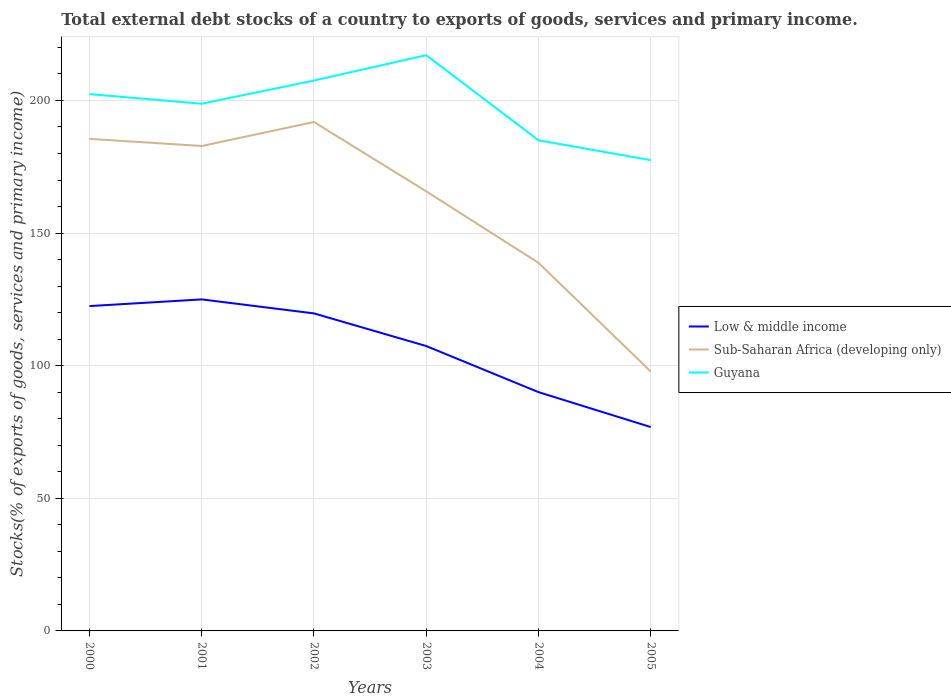Across all years, what is the maximum total debt stocks in Guyana?
Ensure brevity in your answer.  177.49. In which year was the total debt stocks in Guyana maximum?
Your answer should be very brief. 2005. What is the total total debt stocks in Low & middle income in the graph?
Offer a very short reply. 17.38. What is the difference between the highest and the second highest total debt stocks in Guyana?
Your answer should be compact. 39.57. What is the difference between the highest and the lowest total debt stocks in Sub-Saharan Africa (developing only)?
Provide a succinct answer. 4. Is the total debt stocks in Low & middle income strictly greater than the total debt stocks in Sub-Saharan Africa (developing only) over the years?
Keep it short and to the point. Yes. What is the difference between two consecutive major ticks on the Y-axis?
Give a very brief answer. 50. Are the values on the major ticks of Y-axis written in scientific E-notation?
Offer a terse response. No. Does the graph contain grids?
Offer a terse response. Yes. How many legend labels are there?
Your response must be concise. 3. How are the legend labels stacked?
Offer a very short reply. Vertical. What is the title of the graph?
Give a very brief answer. Total external debt stocks of a country to exports of goods, services and primary income. What is the label or title of the X-axis?
Offer a very short reply. Years. What is the label or title of the Y-axis?
Provide a succinct answer. Stocks(% of exports of goods, services and primary income). What is the Stocks(% of exports of goods, services and primary income) in Low & middle income in 2000?
Ensure brevity in your answer.  122.47. What is the Stocks(% of exports of goods, services and primary income) in Sub-Saharan Africa (developing only) in 2000?
Ensure brevity in your answer.  185.52. What is the Stocks(% of exports of goods, services and primary income) of Guyana in 2000?
Provide a short and direct response. 202.39. What is the Stocks(% of exports of goods, services and primary income) of Low & middle income in 2001?
Give a very brief answer. 124.99. What is the Stocks(% of exports of goods, services and primary income) in Sub-Saharan Africa (developing only) in 2001?
Provide a succinct answer. 182.83. What is the Stocks(% of exports of goods, services and primary income) of Guyana in 2001?
Your response must be concise. 198.77. What is the Stocks(% of exports of goods, services and primary income) of Low & middle income in 2002?
Provide a succinct answer. 119.71. What is the Stocks(% of exports of goods, services and primary income) of Sub-Saharan Africa (developing only) in 2002?
Provide a short and direct response. 191.87. What is the Stocks(% of exports of goods, services and primary income) in Guyana in 2002?
Provide a short and direct response. 207.5. What is the Stocks(% of exports of goods, services and primary income) in Low & middle income in 2003?
Keep it short and to the point. 107.4. What is the Stocks(% of exports of goods, services and primary income) in Sub-Saharan Africa (developing only) in 2003?
Give a very brief answer. 165.72. What is the Stocks(% of exports of goods, services and primary income) in Guyana in 2003?
Your answer should be very brief. 217.07. What is the Stocks(% of exports of goods, services and primary income) of Low & middle income in 2004?
Keep it short and to the point. 90.02. What is the Stocks(% of exports of goods, services and primary income) in Sub-Saharan Africa (developing only) in 2004?
Ensure brevity in your answer.  138.77. What is the Stocks(% of exports of goods, services and primary income) in Guyana in 2004?
Provide a short and direct response. 184.98. What is the Stocks(% of exports of goods, services and primary income) in Low & middle income in 2005?
Your answer should be compact. 76.86. What is the Stocks(% of exports of goods, services and primary income) in Sub-Saharan Africa (developing only) in 2005?
Ensure brevity in your answer.  97.79. What is the Stocks(% of exports of goods, services and primary income) in Guyana in 2005?
Give a very brief answer. 177.49. Across all years, what is the maximum Stocks(% of exports of goods, services and primary income) of Low & middle income?
Provide a succinct answer. 124.99. Across all years, what is the maximum Stocks(% of exports of goods, services and primary income) in Sub-Saharan Africa (developing only)?
Provide a short and direct response. 191.87. Across all years, what is the maximum Stocks(% of exports of goods, services and primary income) in Guyana?
Your response must be concise. 217.07. Across all years, what is the minimum Stocks(% of exports of goods, services and primary income) in Low & middle income?
Your response must be concise. 76.86. Across all years, what is the minimum Stocks(% of exports of goods, services and primary income) of Sub-Saharan Africa (developing only)?
Give a very brief answer. 97.79. Across all years, what is the minimum Stocks(% of exports of goods, services and primary income) in Guyana?
Offer a very short reply. 177.49. What is the total Stocks(% of exports of goods, services and primary income) in Low & middle income in the graph?
Provide a succinct answer. 641.46. What is the total Stocks(% of exports of goods, services and primary income) in Sub-Saharan Africa (developing only) in the graph?
Provide a succinct answer. 962.5. What is the total Stocks(% of exports of goods, services and primary income) in Guyana in the graph?
Provide a succinct answer. 1188.2. What is the difference between the Stocks(% of exports of goods, services and primary income) of Low & middle income in 2000 and that in 2001?
Your answer should be compact. -2.51. What is the difference between the Stocks(% of exports of goods, services and primary income) in Sub-Saharan Africa (developing only) in 2000 and that in 2001?
Give a very brief answer. 2.69. What is the difference between the Stocks(% of exports of goods, services and primary income) of Guyana in 2000 and that in 2001?
Give a very brief answer. 3.62. What is the difference between the Stocks(% of exports of goods, services and primary income) in Low & middle income in 2000 and that in 2002?
Offer a very short reply. 2.76. What is the difference between the Stocks(% of exports of goods, services and primary income) of Sub-Saharan Africa (developing only) in 2000 and that in 2002?
Give a very brief answer. -6.35. What is the difference between the Stocks(% of exports of goods, services and primary income) in Guyana in 2000 and that in 2002?
Your answer should be compact. -5.11. What is the difference between the Stocks(% of exports of goods, services and primary income) of Low & middle income in 2000 and that in 2003?
Offer a very short reply. 15.07. What is the difference between the Stocks(% of exports of goods, services and primary income) in Sub-Saharan Africa (developing only) in 2000 and that in 2003?
Your answer should be compact. 19.79. What is the difference between the Stocks(% of exports of goods, services and primary income) of Guyana in 2000 and that in 2003?
Provide a short and direct response. -14.68. What is the difference between the Stocks(% of exports of goods, services and primary income) of Low & middle income in 2000 and that in 2004?
Your answer should be compact. 32.45. What is the difference between the Stocks(% of exports of goods, services and primary income) of Sub-Saharan Africa (developing only) in 2000 and that in 2004?
Provide a succinct answer. 46.75. What is the difference between the Stocks(% of exports of goods, services and primary income) of Guyana in 2000 and that in 2004?
Offer a very short reply. 17.41. What is the difference between the Stocks(% of exports of goods, services and primary income) in Low & middle income in 2000 and that in 2005?
Make the answer very short. 45.61. What is the difference between the Stocks(% of exports of goods, services and primary income) in Sub-Saharan Africa (developing only) in 2000 and that in 2005?
Provide a succinct answer. 87.73. What is the difference between the Stocks(% of exports of goods, services and primary income) of Guyana in 2000 and that in 2005?
Your answer should be compact. 24.9. What is the difference between the Stocks(% of exports of goods, services and primary income) in Low & middle income in 2001 and that in 2002?
Provide a short and direct response. 5.27. What is the difference between the Stocks(% of exports of goods, services and primary income) of Sub-Saharan Africa (developing only) in 2001 and that in 2002?
Keep it short and to the point. -9.04. What is the difference between the Stocks(% of exports of goods, services and primary income) of Guyana in 2001 and that in 2002?
Your answer should be compact. -8.73. What is the difference between the Stocks(% of exports of goods, services and primary income) in Low & middle income in 2001 and that in 2003?
Provide a short and direct response. 17.58. What is the difference between the Stocks(% of exports of goods, services and primary income) of Sub-Saharan Africa (developing only) in 2001 and that in 2003?
Your response must be concise. 17.11. What is the difference between the Stocks(% of exports of goods, services and primary income) of Guyana in 2001 and that in 2003?
Offer a very short reply. -18.3. What is the difference between the Stocks(% of exports of goods, services and primary income) in Low & middle income in 2001 and that in 2004?
Make the answer very short. 34.96. What is the difference between the Stocks(% of exports of goods, services and primary income) in Sub-Saharan Africa (developing only) in 2001 and that in 2004?
Your answer should be compact. 44.06. What is the difference between the Stocks(% of exports of goods, services and primary income) of Guyana in 2001 and that in 2004?
Provide a succinct answer. 13.79. What is the difference between the Stocks(% of exports of goods, services and primary income) in Low & middle income in 2001 and that in 2005?
Offer a terse response. 48.13. What is the difference between the Stocks(% of exports of goods, services and primary income) of Sub-Saharan Africa (developing only) in 2001 and that in 2005?
Keep it short and to the point. 85.04. What is the difference between the Stocks(% of exports of goods, services and primary income) in Guyana in 2001 and that in 2005?
Offer a very short reply. 21.28. What is the difference between the Stocks(% of exports of goods, services and primary income) of Low & middle income in 2002 and that in 2003?
Your answer should be very brief. 12.31. What is the difference between the Stocks(% of exports of goods, services and primary income) in Sub-Saharan Africa (developing only) in 2002 and that in 2003?
Keep it short and to the point. 26.14. What is the difference between the Stocks(% of exports of goods, services and primary income) in Guyana in 2002 and that in 2003?
Ensure brevity in your answer.  -9.57. What is the difference between the Stocks(% of exports of goods, services and primary income) of Low & middle income in 2002 and that in 2004?
Provide a succinct answer. 29.69. What is the difference between the Stocks(% of exports of goods, services and primary income) in Sub-Saharan Africa (developing only) in 2002 and that in 2004?
Make the answer very short. 53.1. What is the difference between the Stocks(% of exports of goods, services and primary income) of Guyana in 2002 and that in 2004?
Your answer should be compact. 22.52. What is the difference between the Stocks(% of exports of goods, services and primary income) of Low & middle income in 2002 and that in 2005?
Provide a short and direct response. 42.86. What is the difference between the Stocks(% of exports of goods, services and primary income) of Sub-Saharan Africa (developing only) in 2002 and that in 2005?
Provide a short and direct response. 94.08. What is the difference between the Stocks(% of exports of goods, services and primary income) in Guyana in 2002 and that in 2005?
Give a very brief answer. 30. What is the difference between the Stocks(% of exports of goods, services and primary income) in Low & middle income in 2003 and that in 2004?
Ensure brevity in your answer.  17.38. What is the difference between the Stocks(% of exports of goods, services and primary income) of Sub-Saharan Africa (developing only) in 2003 and that in 2004?
Ensure brevity in your answer.  26.95. What is the difference between the Stocks(% of exports of goods, services and primary income) of Guyana in 2003 and that in 2004?
Your response must be concise. 32.09. What is the difference between the Stocks(% of exports of goods, services and primary income) of Low & middle income in 2003 and that in 2005?
Make the answer very short. 30.54. What is the difference between the Stocks(% of exports of goods, services and primary income) of Sub-Saharan Africa (developing only) in 2003 and that in 2005?
Your response must be concise. 67.94. What is the difference between the Stocks(% of exports of goods, services and primary income) of Guyana in 2003 and that in 2005?
Offer a very short reply. 39.57. What is the difference between the Stocks(% of exports of goods, services and primary income) in Low & middle income in 2004 and that in 2005?
Keep it short and to the point. 13.16. What is the difference between the Stocks(% of exports of goods, services and primary income) in Sub-Saharan Africa (developing only) in 2004 and that in 2005?
Your answer should be compact. 40.98. What is the difference between the Stocks(% of exports of goods, services and primary income) of Guyana in 2004 and that in 2005?
Make the answer very short. 7.48. What is the difference between the Stocks(% of exports of goods, services and primary income) in Low & middle income in 2000 and the Stocks(% of exports of goods, services and primary income) in Sub-Saharan Africa (developing only) in 2001?
Offer a very short reply. -60.36. What is the difference between the Stocks(% of exports of goods, services and primary income) of Low & middle income in 2000 and the Stocks(% of exports of goods, services and primary income) of Guyana in 2001?
Give a very brief answer. -76.3. What is the difference between the Stocks(% of exports of goods, services and primary income) in Sub-Saharan Africa (developing only) in 2000 and the Stocks(% of exports of goods, services and primary income) in Guyana in 2001?
Your response must be concise. -13.25. What is the difference between the Stocks(% of exports of goods, services and primary income) in Low & middle income in 2000 and the Stocks(% of exports of goods, services and primary income) in Sub-Saharan Africa (developing only) in 2002?
Make the answer very short. -69.39. What is the difference between the Stocks(% of exports of goods, services and primary income) in Low & middle income in 2000 and the Stocks(% of exports of goods, services and primary income) in Guyana in 2002?
Give a very brief answer. -85.03. What is the difference between the Stocks(% of exports of goods, services and primary income) of Sub-Saharan Africa (developing only) in 2000 and the Stocks(% of exports of goods, services and primary income) of Guyana in 2002?
Make the answer very short. -21.98. What is the difference between the Stocks(% of exports of goods, services and primary income) of Low & middle income in 2000 and the Stocks(% of exports of goods, services and primary income) of Sub-Saharan Africa (developing only) in 2003?
Your answer should be compact. -43.25. What is the difference between the Stocks(% of exports of goods, services and primary income) of Low & middle income in 2000 and the Stocks(% of exports of goods, services and primary income) of Guyana in 2003?
Offer a terse response. -94.6. What is the difference between the Stocks(% of exports of goods, services and primary income) of Sub-Saharan Africa (developing only) in 2000 and the Stocks(% of exports of goods, services and primary income) of Guyana in 2003?
Ensure brevity in your answer.  -31.55. What is the difference between the Stocks(% of exports of goods, services and primary income) of Low & middle income in 2000 and the Stocks(% of exports of goods, services and primary income) of Sub-Saharan Africa (developing only) in 2004?
Offer a terse response. -16.3. What is the difference between the Stocks(% of exports of goods, services and primary income) of Low & middle income in 2000 and the Stocks(% of exports of goods, services and primary income) of Guyana in 2004?
Your response must be concise. -62.51. What is the difference between the Stocks(% of exports of goods, services and primary income) in Sub-Saharan Africa (developing only) in 2000 and the Stocks(% of exports of goods, services and primary income) in Guyana in 2004?
Give a very brief answer. 0.54. What is the difference between the Stocks(% of exports of goods, services and primary income) in Low & middle income in 2000 and the Stocks(% of exports of goods, services and primary income) in Sub-Saharan Africa (developing only) in 2005?
Provide a short and direct response. 24.69. What is the difference between the Stocks(% of exports of goods, services and primary income) of Low & middle income in 2000 and the Stocks(% of exports of goods, services and primary income) of Guyana in 2005?
Offer a terse response. -55.02. What is the difference between the Stocks(% of exports of goods, services and primary income) of Sub-Saharan Africa (developing only) in 2000 and the Stocks(% of exports of goods, services and primary income) of Guyana in 2005?
Give a very brief answer. 8.02. What is the difference between the Stocks(% of exports of goods, services and primary income) in Low & middle income in 2001 and the Stocks(% of exports of goods, services and primary income) in Sub-Saharan Africa (developing only) in 2002?
Give a very brief answer. -66.88. What is the difference between the Stocks(% of exports of goods, services and primary income) in Low & middle income in 2001 and the Stocks(% of exports of goods, services and primary income) in Guyana in 2002?
Give a very brief answer. -82.51. What is the difference between the Stocks(% of exports of goods, services and primary income) of Sub-Saharan Africa (developing only) in 2001 and the Stocks(% of exports of goods, services and primary income) of Guyana in 2002?
Provide a succinct answer. -24.67. What is the difference between the Stocks(% of exports of goods, services and primary income) of Low & middle income in 2001 and the Stocks(% of exports of goods, services and primary income) of Sub-Saharan Africa (developing only) in 2003?
Provide a short and direct response. -40.74. What is the difference between the Stocks(% of exports of goods, services and primary income) of Low & middle income in 2001 and the Stocks(% of exports of goods, services and primary income) of Guyana in 2003?
Give a very brief answer. -92.08. What is the difference between the Stocks(% of exports of goods, services and primary income) of Sub-Saharan Africa (developing only) in 2001 and the Stocks(% of exports of goods, services and primary income) of Guyana in 2003?
Provide a succinct answer. -34.24. What is the difference between the Stocks(% of exports of goods, services and primary income) in Low & middle income in 2001 and the Stocks(% of exports of goods, services and primary income) in Sub-Saharan Africa (developing only) in 2004?
Provide a succinct answer. -13.78. What is the difference between the Stocks(% of exports of goods, services and primary income) of Low & middle income in 2001 and the Stocks(% of exports of goods, services and primary income) of Guyana in 2004?
Your response must be concise. -59.99. What is the difference between the Stocks(% of exports of goods, services and primary income) of Sub-Saharan Africa (developing only) in 2001 and the Stocks(% of exports of goods, services and primary income) of Guyana in 2004?
Offer a very short reply. -2.15. What is the difference between the Stocks(% of exports of goods, services and primary income) in Low & middle income in 2001 and the Stocks(% of exports of goods, services and primary income) in Sub-Saharan Africa (developing only) in 2005?
Offer a very short reply. 27.2. What is the difference between the Stocks(% of exports of goods, services and primary income) in Low & middle income in 2001 and the Stocks(% of exports of goods, services and primary income) in Guyana in 2005?
Offer a very short reply. -52.51. What is the difference between the Stocks(% of exports of goods, services and primary income) in Sub-Saharan Africa (developing only) in 2001 and the Stocks(% of exports of goods, services and primary income) in Guyana in 2005?
Your response must be concise. 5.33. What is the difference between the Stocks(% of exports of goods, services and primary income) of Low & middle income in 2002 and the Stocks(% of exports of goods, services and primary income) of Sub-Saharan Africa (developing only) in 2003?
Keep it short and to the point. -46.01. What is the difference between the Stocks(% of exports of goods, services and primary income) of Low & middle income in 2002 and the Stocks(% of exports of goods, services and primary income) of Guyana in 2003?
Ensure brevity in your answer.  -97.35. What is the difference between the Stocks(% of exports of goods, services and primary income) in Sub-Saharan Africa (developing only) in 2002 and the Stocks(% of exports of goods, services and primary income) in Guyana in 2003?
Offer a terse response. -25.2. What is the difference between the Stocks(% of exports of goods, services and primary income) in Low & middle income in 2002 and the Stocks(% of exports of goods, services and primary income) in Sub-Saharan Africa (developing only) in 2004?
Give a very brief answer. -19.06. What is the difference between the Stocks(% of exports of goods, services and primary income) in Low & middle income in 2002 and the Stocks(% of exports of goods, services and primary income) in Guyana in 2004?
Keep it short and to the point. -65.26. What is the difference between the Stocks(% of exports of goods, services and primary income) in Sub-Saharan Africa (developing only) in 2002 and the Stocks(% of exports of goods, services and primary income) in Guyana in 2004?
Offer a terse response. 6.89. What is the difference between the Stocks(% of exports of goods, services and primary income) in Low & middle income in 2002 and the Stocks(% of exports of goods, services and primary income) in Sub-Saharan Africa (developing only) in 2005?
Offer a very short reply. 21.93. What is the difference between the Stocks(% of exports of goods, services and primary income) of Low & middle income in 2002 and the Stocks(% of exports of goods, services and primary income) of Guyana in 2005?
Offer a terse response. -57.78. What is the difference between the Stocks(% of exports of goods, services and primary income) in Sub-Saharan Africa (developing only) in 2002 and the Stocks(% of exports of goods, services and primary income) in Guyana in 2005?
Keep it short and to the point. 14.37. What is the difference between the Stocks(% of exports of goods, services and primary income) of Low & middle income in 2003 and the Stocks(% of exports of goods, services and primary income) of Sub-Saharan Africa (developing only) in 2004?
Your response must be concise. -31.37. What is the difference between the Stocks(% of exports of goods, services and primary income) in Low & middle income in 2003 and the Stocks(% of exports of goods, services and primary income) in Guyana in 2004?
Offer a very short reply. -77.58. What is the difference between the Stocks(% of exports of goods, services and primary income) of Sub-Saharan Africa (developing only) in 2003 and the Stocks(% of exports of goods, services and primary income) of Guyana in 2004?
Offer a terse response. -19.25. What is the difference between the Stocks(% of exports of goods, services and primary income) of Low & middle income in 2003 and the Stocks(% of exports of goods, services and primary income) of Sub-Saharan Africa (developing only) in 2005?
Provide a succinct answer. 9.62. What is the difference between the Stocks(% of exports of goods, services and primary income) in Low & middle income in 2003 and the Stocks(% of exports of goods, services and primary income) in Guyana in 2005?
Make the answer very short. -70.09. What is the difference between the Stocks(% of exports of goods, services and primary income) of Sub-Saharan Africa (developing only) in 2003 and the Stocks(% of exports of goods, services and primary income) of Guyana in 2005?
Your response must be concise. -11.77. What is the difference between the Stocks(% of exports of goods, services and primary income) of Low & middle income in 2004 and the Stocks(% of exports of goods, services and primary income) of Sub-Saharan Africa (developing only) in 2005?
Ensure brevity in your answer.  -7.76. What is the difference between the Stocks(% of exports of goods, services and primary income) in Low & middle income in 2004 and the Stocks(% of exports of goods, services and primary income) in Guyana in 2005?
Your response must be concise. -87.47. What is the difference between the Stocks(% of exports of goods, services and primary income) in Sub-Saharan Africa (developing only) in 2004 and the Stocks(% of exports of goods, services and primary income) in Guyana in 2005?
Provide a succinct answer. -38.72. What is the average Stocks(% of exports of goods, services and primary income) in Low & middle income per year?
Provide a succinct answer. 106.91. What is the average Stocks(% of exports of goods, services and primary income) in Sub-Saharan Africa (developing only) per year?
Give a very brief answer. 160.42. What is the average Stocks(% of exports of goods, services and primary income) of Guyana per year?
Offer a terse response. 198.03. In the year 2000, what is the difference between the Stocks(% of exports of goods, services and primary income) of Low & middle income and Stocks(% of exports of goods, services and primary income) of Sub-Saharan Africa (developing only)?
Provide a short and direct response. -63.05. In the year 2000, what is the difference between the Stocks(% of exports of goods, services and primary income) in Low & middle income and Stocks(% of exports of goods, services and primary income) in Guyana?
Your answer should be compact. -79.92. In the year 2000, what is the difference between the Stocks(% of exports of goods, services and primary income) of Sub-Saharan Africa (developing only) and Stocks(% of exports of goods, services and primary income) of Guyana?
Offer a terse response. -16.87. In the year 2001, what is the difference between the Stocks(% of exports of goods, services and primary income) of Low & middle income and Stocks(% of exports of goods, services and primary income) of Sub-Saharan Africa (developing only)?
Your answer should be very brief. -57.84. In the year 2001, what is the difference between the Stocks(% of exports of goods, services and primary income) in Low & middle income and Stocks(% of exports of goods, services and primary income) in Guyana?
Provide a succinct answer. -73.78. In the year 2001, what is the difference between the Stocks(% of exports of goods, services and primary income) in Sub-Saharan Africa (developing only) and Stocks(% of exports of goods, services and primary income) in Guyana?
Your answer should be very brief. -15.94. In the year 2002, what is the difference between the Stocks(% of exports of goods, services and primary income) in Low & middle income and Stocks(% of exports of goods, services and primary income) in Sub-Saharan Africa (developing only)?
Offer a terse response. -72.15. In the year 2002, what is the difference between the Stocks(% of exports of goods, services and primary income) of Low & middle income and Stocks(% of exports of goods, services and primary income) of Guyana?
Offer a very short reply. -87.79. In the year 2002, what is the difference between the Stocks(% of exports of goods, services and primary income) in Sub-Saharan Africa (developing only) and Stocks(% of exports of goods, services and primary income) in Guyana?
Ensure brevity in your answer.  -15.63. In the year 2003, what is the difference between the Stocks(% of exports of goods, services and primary income) of Low & middle income and Stocks(% of exports of goods, services and primary income) of Sub-Saharan Africa (developing only)?
Give a very brief answer. -58.32. In the year 2003, what is the difference between the Stocks(% of exports of goods, services and primary income) of Low & middle income and Stocks(% of exports of goods, services and primary income) of Guyana?
Provide a short and direct response. -109.67. In the year 2003, what is the difference between the Stocks(% of exports of goods, services and primary income) in Sub-Saharan Africa (developing only) and Stocks(% of exports of goods, services and primary income) in Guyana?
Offer a very short reply. -51.34. In the year 2004, what is the difference between the Stocks(% of exports of goods, services and primary income) in Low & middle income and Stocks(% of exports of goods, services and primary income) in Sub-Saharan Africa (developing only)?
Ensure brevity in your answer.  -48.75. In the year 2004, what is the difference between the Stocks(% of exports of goods, services and primary income) in Low & middle income and Stocks(% of exports of goods, services and primary income) in Guyana?
Provide a succinct answer. -94.95. In the year 2004, what is the difference between the Stocks(% of exports of goods, services and primary income) in Sub-Saharan Africa (developing only) and Stocks(% of exports of goods, services and primary income) in Guyana?
Ensure brevity in your answer.  -46.21. In the year 2005, what is the difference between the Stocks(% of exports of goods, services and primary income) of Low & middle income and Stocks(% of exports of goods, services and primary income) of Sub-Saharan Africa (developing only)?
Offer a very short reply. -20.93. In the year 2005, what is the difference between the Stocks(% of exports of goods, services and primary income) in Low & middle income and Stocks(% of exports of goods, services and primary income) in Guyana?
Make the answer very short. -100.64. In the year 2005, what is the difference between the Stocks(% of exports of goods, services and primary income) of Sub-Saharan Africa (developing only) and Stocks(% of exports of goods, services and primary income) of Guyana?
Provide a succinct answer. -79.71. What is the ratio of the Stocks(% of exports of goods, services and primary income) in Low & middle income in 2000 to that in 2001?
Provide a succinct answer. 0.98. What is the ratio of the Stocks(% of exports of goods, services and primary income) of Sub-Saharan Africa (developing only) in 2000 to that in 2001?
Provide a short and direct response. 1.01. What is the ratio of the Stocks(% of exports of goods, services and primary income) in Guyana in 2000 to that in 2001?
Your answer should be very brief. 1.02. What is the ratio of the Stocks(% of exports of goods, services and primary income) of Sub-Saharan Africa (developing only) in 2000 to that in 2002?
Keep it short and to the point. 0.97. What is the ratio of the Stocks(% of exports of goods, services and primary income) in Guyana in 2000 to that in 2002?
Ensure brevity in your answer.  0.98. What is the ratio of the Stocks(% of exports of goods, services and primary income) in Low & middle income in 2000 to that in 2003?
Keep it short and to the point. 1.14. What is the ratio of the Stocks(% of exports of goods, services and primary income) in Sub-Saharan Africa (developing only) in 2000 to that in 2003?
Your response must be concise. 1.12. What is the ratio of the Stocks(% of exports of goods, services and primary income) in Guyana in 2000 to that in 2003?
Make the answer very short. 0.93. What is the ratio of the Stocks(% of exports of goods, services and primary income) in Low & middle income in 2000 to that in 2004?
Provide a short and direct response. 1.36. What is the ratio of the Stocks(% of exports of goods, services and primary income) in Sub-Saharan Africa (developing only) in 2000 to that in 2004?
Offer a terse response. 1.34. What is the ratio of the Stocks(% of exports of goods, services and primary income) in Guyana in 2000 to that in 2004?
Ensure brevity in your answer.  1.09. What is the ratio of the Stocks(% of exports of goods, services and primary income) in Low & middle income in 2000 to that in 2005?
Provide a short and direct response. 1.59. What is the ratio of the Stocks(% of exports of goods, services and primary income) in Sub-Saharan Africa (developing only) in 2000 to that in 2005?
Make the answer very short. 1.9. What is the ratio of the Stocks(% of exports of goods, services and primary income) in Guyana in 2000 to that in 2005?
Offer a terse response. 1.14. What is the ratio of the Stocks(% of exports of goods, services and primary income) in Low & middle income in 2001 to that in 2002?
Give a very brief answer. 1.04. What is the ratio of the Stocks(% of exports of goods, services and primary income) of Sub-Saharan Africa (developing only) in 2001 to that in 2002?
Ensure brevity in your answer.  0.95. What is the ratio of the Stocks(% of exports of goods, services and primary income) in Guyana in 2001 to that in 2002?
Your answer should be very brief. 0.96. What is the ratio of the Stocks(% of exports of goods, services and primary income) in Low & middle income in 2001 to that in 2003?
Your answer should be very brief. 1.16. What is the ratio of the Stocks(% of exports of goods, services and primary income) of Sub-Saharan Africa (developing only) in 2001 to that in 2003?
Make the answer very short. 1.1. What is the ratio of the Stocks(% of exports of goods, services and primary income) in Guyana in 2001 to that in 2003?
Your response must be concise. 0.92. What is the ratio of the Stocks(% of exports of goods, services and primary income) in Low & middle income in 2001 to that in 2004?
Make the answer very short. 1.39. What is the ratio of the Stocks(% of exports of goods, services and primary income) in Sub-Saharan Africa (developing only) in 2001 to that in 2004?
Provide a succinct answer. 1.32. What is the ratio of the Stocks(% of exports of goods, services and primary income) in Guyana in 2001 to that in 2004?
Make the answer very short. 1.07. What is the ratio of the Stocks(% of exports of goods, services and primary income) in Low & middle income in 2001 to that in 2005?
Your answer should be very brief. 1.63. What is the ratio of the Stocks(% of exports of goods, services and primary income) in Sub-Saharan Africa (developing only) in 2001 to that in 2005?
Offer a very short reply. 1.87. What is the ratio of the Stocks(% of exports of goods, services and primary income) of Guyana in 2001 to that in 2005?
Your answer should be compact. 1.12. What is the ratio of the Stocks(% of exports of goods, services and primary income) in Low & middle income in 2002 to that in 2003?
Offer a very short reply. 1.11. What is the ratio of the Stocks(% of exports of goods, services and primary income) in Sub-Saharan Africa (developing only) in 2002 to that in 2003?
Offer a very short reply. 1.16. What is the ratio of the Stocks(% of exports of goods, services and primary income) in Guyana in 2002 to that in 2003?
Offer a terse response. 0.96. What is the ratio of the Stocks(% of exports of goods, services and primary income) in Low & middle income in 2002 to that in 2004?
Your answer should be compact. 1.33. What is the ratio of the Stocks(% of exports of goods, services and primary income) of Sub-Saharan Africa (developing only) in 2002 to that in 2004?
Your answer should be very brief. 1.38. What is the ratio of the Stocks(% of exports of goods, services and primary income) in Guyana in 2002 to that in 2004?
Your response must be concise. 1.12. What is the ratio of the Stocks(% of exports of goods, services and primary income) in Low & middle income in 2002 to that in 2005?
Keep it short and to the point. 1.56. What is the ratio of the Stocks(% of exports of goods, services and primary income) in Sub-Saharan Africa (developing only) in 2002 to that in 2005?
Provide a short and direct response. 1.96. What is the ratio of the Stocks(% of exports of goods, services and primary income) in Guyana in 2002 to that in 2005?
Your answer should be compact. 1.17. What is the ratio of the Stocks(% of exports of goods, services and primary income) in Low & middle income in 2003 to that in 2004?
Your answer should be compact. 1.19. What is the ratio of the Stocks(% of exports of goods, services and primary income) of Sub-Saharan Africa (developing only) in 2003 to that in 2004?
Provide a short and direct response. 1.19. What is the ratio of the Stocks(% of exports of goods, services and primary income) in Guyana in 2003 to that in 2004?
Give a very brief answer. 1.17. What is the ratio of the Stocks(% of exports of goods, services and primary income) in Low & middle income in 2003 to that in 2005?
Make the answer very short. 1.4. What is the ratio of the Stocks(% of exports of goods, services and primary income) of Sub-Saharan Africa (developing only) in 2003 to that in 2005?
Give a very brief answer. 1.69. What is the ratio of the Stocks(% of exports of goods, services and primary income) in Guyana in 2003 to that in 2005?
Provide a short and direct response. 1.22. What is the ratio of the Stocks(% of exports of goods, services and primary income) in Low & middle income in 2004 to that in 2005?
Provide a short and direct response. 1.17. What is the ratio of the Stocks(% of exports of goods, services and primary income) in Sub-Saharan Africa (developing only) in 2004 to that in 2005?
Keep it short and to the point. 1.42. What is the ratio of the Stocks(% of exports of goods, services and primary income) of Guyana in 2004 to that in 2005?
Provide a short and direct response. 1.04. What is the difference between the highest and the second highest Stocks(% of exports of goods, services and primary income) of Low & middle income?
Offer a very short reply. 2.51. What is the difference between the highest and the second highest Stocks(% of exports of goods, services and primary income) in Sub-Saharan Africa (developing only)?
Provide a succinct answer. 6.35. What is the difference between the highest and the second highest Stocks(% of exports of goods, services and primary income) in Guyana?
Your answer should be compact. 9.57. What is the difference between the highest and the lowest Stocks(% of exports of goods, services and primary income) of Low & middle income?
Offer a terse response. 48.13. What is the difference between the highest and the lowest Stocks(% of exports of goods, services and primary income) of Sub-Saharan Africa (developing only)?
Your answer should be very brief. 94.08. What is the difference between the highest and the lowest Stocks(% of exports of goods, services and primary income) in Guyana?
Your answer should be compact. 39.57. 